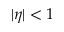<formula> <loc_0><loc_0><loc_500><loc_500>| \eta | < 1</formula> 